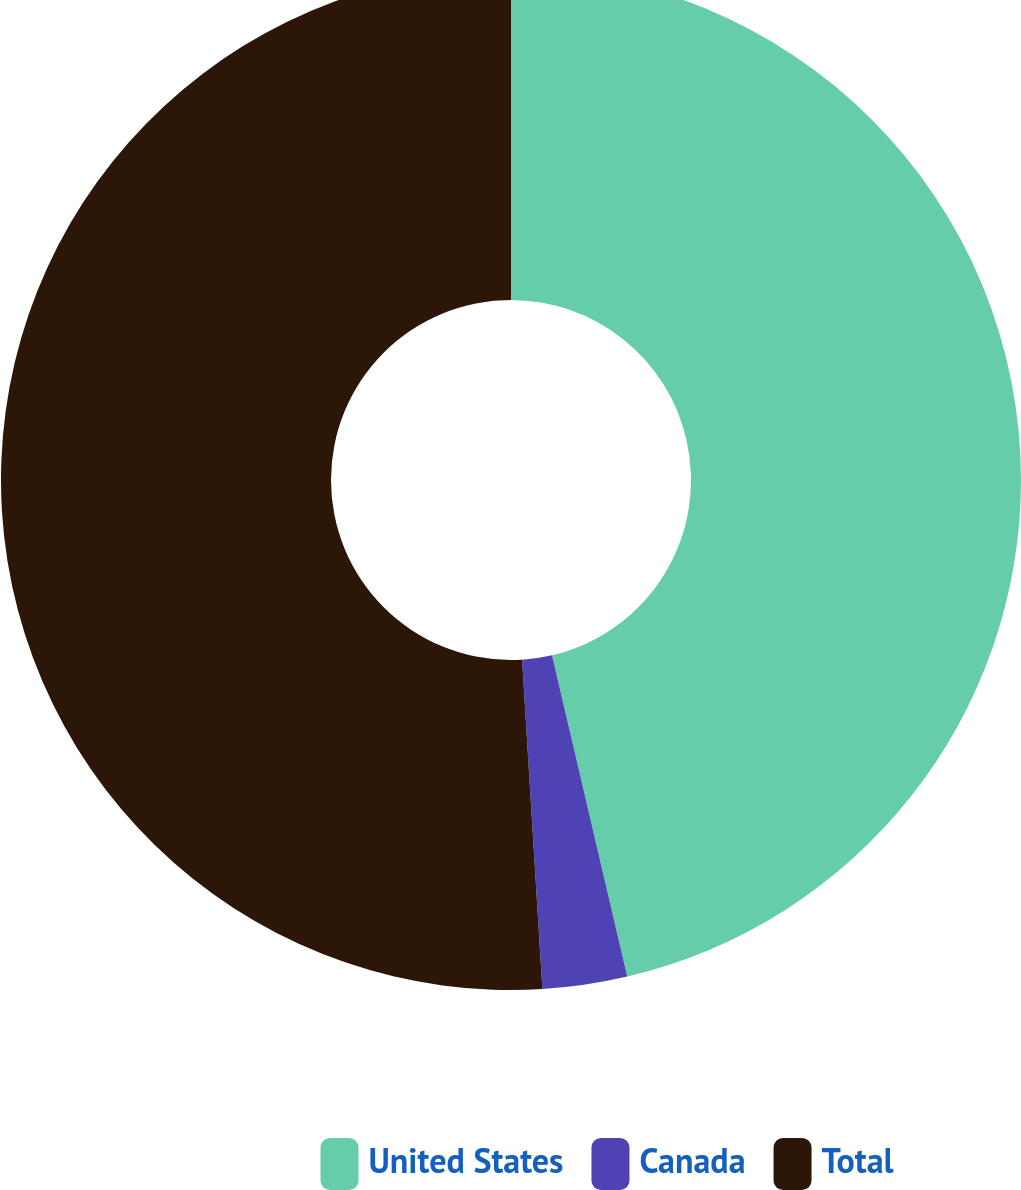Convert chart to OTSL. <chart><loc_0><loc_0><loc_500><loc_500><pie_chart><fcel>United States<fcel>Canada<fcel>Total<nl><fcel>46.34%<fcel>2.68%<fcel>50.98%<nl></chart> 